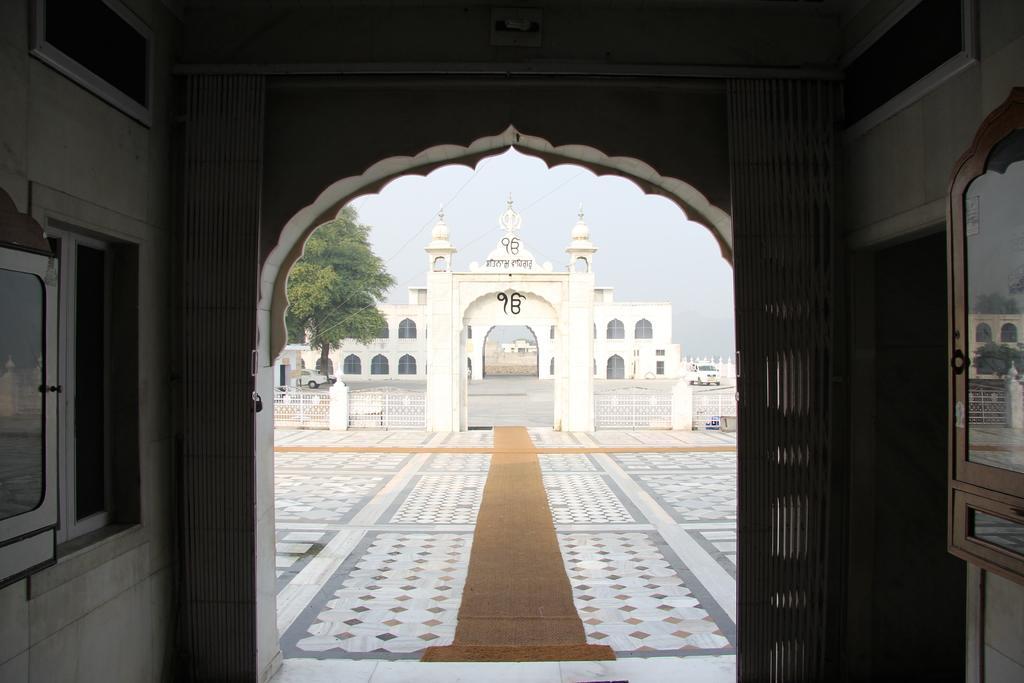Could you give a brief overview of what you see in this image? In this image I can see a building which is in white color. I can also see a window, trees in green color and sky in white color. 